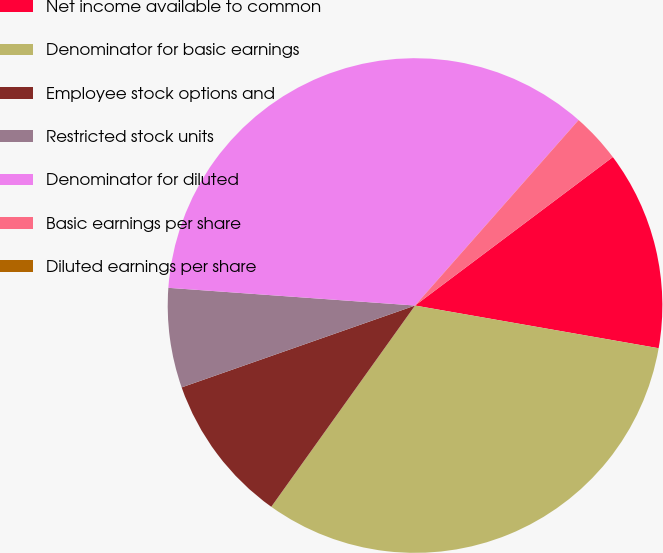Convert chart. <chart><loc_0><loc_0><loc_500><loc_500><pie_chart><fcel>Net income available to common<fcel>Denominator for basic earnings<fcel>Employee stock options and<fcel>Restricted stock units<fcel>Denominator for diluted<fcel>Basic earnings per share<fcel>Diluted earnings per share<nl><fcel>13.01%<fcel>32.11%<fcel>9.76%<fcel>6.51%<fcel>35.36%<fcel>3.25%<fcel>0.0%<nl></chart> 